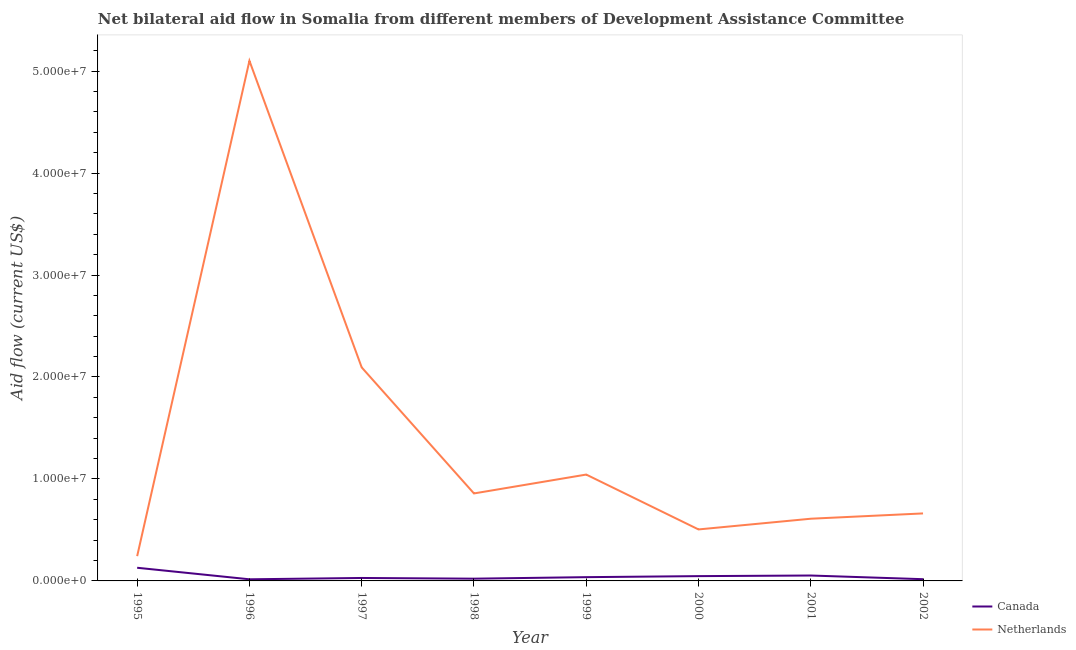What is the amount of aid given by canada in 1995?
Make the answer very short. 1.29e+06. Across all years, what is the maximum amount of aid given by canada?
Provide a short and direct response. 1.29e+06. Across all years, what is the minimum amount of aid given by netherlands?
Offer a very short reply. 2.43e+06. In which year was the amount of aid given by netherlands minimum?
Keep it short and to the point. 1995. What is the total amount of aid given by canada in the graph?
Give a very brief answer. 3.50e+06. What is the difference between the amount of aid given by netherlands in 1998 and that in 1999?
Your answer should be compact. -1.85e+06. What is the difference between the amount of aid given by netherlands in 1997 and the amount of aid given by canada in 1998?
Ensure brevity in your answer.  2.07e+07. What is the average amount of aid given by netherlands per year?
Your response must be concise. 1.39e+07. In the year 2000, what is the difference between the amount of aid given by canada and amount of aid given by netherlands?
Your answer should be compact. -4.58e+06. What is the ratio of the amount of aid given by netherlands in 1999 to that in 2000?
Provide a succinct answer. 2.07. What is the difference between the highest and the second highest amount of aid given by canada?
Offer a terse response. 7.60e+05. What is the difference between the highest and the lowest amount of aid given by netherlands?
Provide a succinct answer. 4.86e+07. In how many years, is the amount of aid given by netherlands greater than the average amount of aid given by netherlands taken over all years?
Offer a terse response. 2. Is the sum of the amount of aid given by netherlands in 2000 and 2002 greater than the maximum amount of aid given by canada across all years?
Your response must be concise. Yes. Is the amount of aid given by netherlands strictly greater than the amount of aid given by canada over the years?
Your answer should be very brief. Yes. Is the amount of aid given by canada strictly less than the amount of aid given by netherlands over the years?
Give a very brief answer. Yes. Does the graph contain any zero values?
Offer a terse response. No. Where does the legend appear in the graph?
Ensure brevity in your answer.  Bottom right. How are the legend labels stacked?
Your answer should be compact. Vertical. What is the title of the graph?
Make the answer very short. Net bilateral aid flow in Somalia from different members of Development Assistance Committee. What is the label or title of the X-axis?
Provide a succinct answer. Year. What is the Aid flow (current US$) of Canada in 1995?
Your response must be concise. 1.29e+06. What is the Aid flow (current US$) of Netherlands in 1995?
Provide a succinct answer. 2.43e+06. What is the Aid flow (current US$) in Canada in 1996?
Give a very brief answer. 1.60e+05. What is the Aid flow (current US$) in Netherlands in 1996?
Your answer should be very brief. 5.10e+07. What is the Aid flow (current US$) of Canada in 1997?
Your response must be concise. 2.90e+05. What is the Aid flow (current US$) of Netherlands in 1997?
Ensure brevity in your answer.  2.09e+07. What is the Aid flow (current US$) of Canada in 1998?
Offer a terse response. 2.20e+05. What is the Aid flow (current US$) in Netherlands in 1998?
Your answer should be very brief. 8.58e+06. What is the Aid flow (current US$) in Canada in 1999?
Keep it short and to the point. 3.70e+05. What is the Aid flow (current US$) in Netherlands in 1999?
Your response must be concise. 1.04e+07. What is the Aid flow (current US$) of Canada in 2000?
Provide a succinct answer. 4.70e+05. What is the Aid flow (current US$) in Netherlands in 2000?
Your answer should be very brief. 5.05e+06. What is the Aid flow (current US$) in Canada in 2001?
Make the answer very short. 5.30e+05. What is the Aid flow (current US$) in Netherlands in 2001?
Your answer should be compact. 6.10e+06. What is the Aid flow (current US$) in Netherlands in 2002?
Give a very brief answer. 6.62e+06. Across all years, what is the maximum Aid flow (current US$) of Canada?
Ensure brevity in your answer.  1.29e+06. Across all years, what is the maximum Aid flow (current US$) of Netherlands?
Offer a terse response. 5.10e+07. Across all years, what is the minimum Aid flow (current US$) in Canada?
Offer a very short reply. 1.60e+05. Across all years, what is the minimum Aid flow (current US$) in Netherlands?
Give a very brief answer. 2.43e+06. What is the total Aid flow (current US$) in Canada in the graph?
Make the answer very short. 3.50e+06. What is the total Aid flow (current US$) of Netherlands in the graph?
Provide a short and direct response. 1.11e+08. What is the difference between the Aid flow (current US$) of Canada in 1995 and that in 1996?
Provide a succinct answer. 1.13e+06. What is the difference between the Aid flow (current US$) in Netherlands in 1995 and that in 1996?
Provide a succinct answer. -4.86e+07. What is the difference between the Aid flow (current US$) in Netherlands in 1995 and that in 1997?
Offer a terse response. -1.85e+07. What is the difference between the Aid flow (current US$) of Canada in 1995 and that in 1998?
Ensure brevity in your answer.  1.07e+06. What is the difference between the Aid flow (current US$) in Netherlands in 1995 and that in 1998?
Make the answer very short. -6.15e+06. What is the difference between the Aid flow (current US$) in Canada in 1995 and that in 1999?
Your answer should be compact. 9.20e+05. What is the difference between the Aid flow (current US$) of Netherlands in 1995 and that in 1999?
Offer a terse response. -8.00e+06. What is the difference between the Aid flow (current US$) in Canada in 1995 and that in 2000?
Provide a succinct answer. 8.20e+05. What is the difference between the Aid flow (current US$) of Netherlands in 1995 and that in 2000?
Offer a very short reply. -2.62e+06. What is the difference between the Aid flow (current US$) in Canada in 1995 and that in 2001?
Your answer should be very brief. 7.60e+05. What is the difference between the Aid flow (current US$) in Netherlands in 1995 and that in 2001?
Ensure brevity in your answer.  -3.67e+06. What is the difference between the Aid flow (current US$) of Canada in 1995 and that in 2002?
Your answer should be very brief. 1.12e+06. What is the difference between the Aid flow (current US$) of Netherlands in 1995 and that in 2002?
Make the answer very short. -4.19e+06. What is the difference between the Aid flow (current US$) in Canada in 1996 and that in 1997?
Your answer should be very brief. -1.30e+05. What is the difference between the Aid flow (current US$) in Netherlands in 1996 and that in 1997?
Your answer should be compact. 3.01e+07. What is the difference between the Aid flow (current US$) in Canada in 1996 and that in 1998?
Make the answer very short. -6.00e+04. What is the difference between the Aid flow (current US$) of Netherlands in 1996 and that in 1998?
Provide a short and direct response. 4.24e+07. What is the difference between the Aid flow (current US$) of Netherlands in 1996 and that in 1999?
Make the answer very short. 4.06e+07. What is the difference between the Aid flow (current US$) in Canada in 1996 and that in 2000?
Keep it short and to the point. -3.10e+05. What is the difference between the Aid flow (current US$) in Netherlands in 1996 and that in 2000?
Provide a short and direct response. 4.60e+07. What is the difference between the Aid flow (current US$) in Canada in 1996 and that in 2001?
Provide a short and direct response. -3.70e+05. What is the difference between the Aid flow (current US$) of Netherlands in 1996 and that in 2001?
Offer a very short reply. 4.49e+07. What is the difference between the Aid flow (current US$) in Canada in 1996 and that in 2002?
Provide a succinct answer. -10000. What is the difference between the Aid flow (current US$) of Netherlands in 1996 and that in 2002?
Your answer should be compact. 4.44e+07. What is the difference between the Aid flow (current US$) of Canada in 1997 and that in 1998?
Keep it short and to the point. 7.00e+04. What is the difference between the Aid flow (current US$) of Netherlands in 1997 and that in 1998?
Offer a very short reply. 1.24e+07. What is the difference between the Aid flow (current US$) of Netherlands in 1997 and that in 1999?
Offer a very short reply. 1.05e+07. What is the difference between the Aid flow (current US$) in Canada in 1997 and that in 2000?
Your answer should be compact. -1.80e+05. What is the difference between the Aid flow (current US$) of Netherlands in 1997 and that in 2000?
Give a very brief answer. 1.59e+07. What is the difference between the Aid flow (current US$) in Canada in 1997 and that in 2001?
Keep it short and to the point. -2.40e+05. What is the difference between the Aid flow (current US$) in Netherlands in 1997 and that in 2001?
Offer a very short reply. 1.48e+07. What is the difference between the Aid flow (current US$) in Netherlands in 1997 and that in 2002?
Your answer should be compact. 1.43e+07. What is the difference between the Aid flow (current US$) of Netherlands in 1998 and that in 1999?
Ensure brevity in your answer.  -1.85e+06. What is the difference between the Aid flow (current US$) in Canada in 1998 and that in 2000?
Offer a terse response. -2.50e+05. What is the difference between the Aid flow (current US$) of Netherlands in 1998 and that in 2000?
Your response must be concise. 3.53e+06. What is the difference between the Aid flow (current US$) in Canada in 1998 and that in 2001?
Keep it short and to the point. -3.10e+05. What is the difference between the Aid flow (current US$) in Netherlands in 1998 and that in 2001?
Your answer should be compact. 2.48e+06. What is the difference between the Aid flow (current US$) in Netherlands in 1998 and that in 2002?
Your answer should be compact. 1.96e+06. What is the difference between the Aid flow (current US$) in Netherlands in 1999 and that in 2000?
Your answer should be very brief. 5.38e+06. What is the difference between the Aid flow (current US$) in Canada in 1999 and that in 2001?
Make the answer very short. -1.60e+05. What is the difference between the Aid flow (current US$) of Netherlands in 1999 and that in 2001?
Provide a succinct answer. 4.33e+06. What is the difference between the Aid flow (current US$) in Canada in 1999 and that in 2002?
Offer a very short reply. 2.00e+05. What is the difference between the Aid flow (current US$) of Netherlands in 1999 and that in 2002?
Provide a short and direct response. 3.81e+06. What is the difference between the Aid flow (current US$) in Canada in 2000 and that in 2001?
Ensure brevity in your answer.  -6.00e+04. What is the difference between the Aid flow (current US$) of Netherlands in 2000 and that in 2001?
Make the answer very short. -1.05e+06. What is the difference between the Aid flow (current US$) in Netherlands in 2000 and that in 2002?
Keep it short and to the point. -1.57e+06. What is the difference between the Aid flow (current US$) in Netherlands in 2001 and that in 2002?
Provide a succinct answer. -5.20e+05. What is the difference between the Aid flow (current US$) in Canada in 1995 and the Aid flow (current US$) in Netherlands in 1996?
Keep it short and to the point. -4.97e+07. What is the difference between the Aid flow (current US$) of Canada in 1995 and the Aid flow (current US$) of Netherlands in 1997?
Offer a very short reply. -1.96e+07. What is the difference between the Aid flow (current US$) in Canada in 1995 and the Aid flow (current US$) in Netherlands in 1998?
Offer a terse response. -7.29e+06. What is the difference between the Aid flow (current US$) in Canada in 1995 and the Aid flow (current US$) in Netherlands in 1999?
Make the answer very short. -9.14e+06. What is the difference between the Aid flow (current US$) of Canada in 1995 and the Aid flow (current US$) of Netherlands in 2000?
Ensure brevity in your answer.  -3.76e+06. What is the difference between the Aid flow (current US$) of Canada in 1995 and the Aid flow (current US$) of Netherlands in 2001?
Make the answer very short. -4.81e+06. What is the difference between the Aid flow (current US$) of Canada in 1995 and the Aid flow (current US$) of Netherlands in 2002?
Offer a very short reply. -5.33e+06. What is the difference between the Aid flow (current US$) of Canada in 1996 and the Aid flow (current US$) of Netherlands in 1997?
Provide a short and direct response. -2.08e+07. What is the difference between the Aid flow (current US$) of Canada in 1996 and the Aid flow (current US$) of Netherlands in 1998?
Provide a short and direct response. -8.42e+06. What is the difference between the Aid flow (current US$) of Canada in 1996 and the Aid flow (current US$) of Netherlands in 1999?
Offer a very short reply. -1.03e+07. What is the difference between the Aid flow (current US$) in Canada in 1996 and the Aid flow (current US$) in Netherlands in 2000?
Keep it short and to the point. -4.89e+06. What is the difference between the Aid flow (current US$) of Canada in 1996 and the Aid flow (current US$) of Netherlands in 2001?
Make the answer very short. -5.94e+06. What is the difference between the Aid flow (current US$) of Canada in 1996 and the Aid flow (current US$) of Netherlands in 2002?
Offer a very short reply. -6.46e+06. What is the difference between the Aid flow (current US$) of Canada in 1997 and the Aid flow (current US$) of Netherlands in 1998?
Offer a terse response. -8.29e+06. What is the difference between the Aid flow (current US$) in Canada in 1997 and the Aid flow (current US$) in Netherlands in 1999?
Your answer should be very brief. -1.01e+07. What is the difference between the Aid flow (current US$) in Canada in 1997 and the Aid flow (current US$) in Netherlands in 2000?
Give a very brief answer. -4.76e+06. What is the difference between the Aid flow (current US$) of Canada in 1997 and the Aid flow (current US$) of Netherlands in 2001?
Keep it short and to the point. -5.81e+06. What is the difference between the Aid flow (current US$) of Canada in 1997 and the Aid flow (current US$) of Netherlands in 2002?
Provide a short and direct response. -6.33e+06. What is the difference between the Aid flow (current US$) of Canada in 1998 and the Aid flow (current US$) of Netherlands in 1999?
Your response must be concise. -1.02e+07. What is the difference between the Aid flow (current US$) of Canada in 1998 and the Aid flow (current US$) of Netherlands in 2000?
Provide a succinct answer. -4.83e+06. What is the difference between the Aid flow (current US$) in Canada in 1998 and the Aid flow (current US$) in Netherlands in 2001?
Provide a succinct answer. -5.88e+06. What is the difference between the Aid flow (current US$) of Canada in 1998 and the Aid flow (current US$) of Netherlands in 2002?
Your response must be concise. -6.40e+06. What is the difference between the Aid flow (current US$) in Canada in 1999 and the Aid flow (current US$) in Netherlands in 2000?
Keep it short and to the point. -4.68e+06. What is the difference between the Aid flow (current US$) in Canada in 1999 and the Aid flow (current US$) in Netherlands in 2001?
Offer a terse response. -5.73e+06. What is the difference between the Aid flow (current US$) in Canada in 1999 and the Aid flow (current US$) in Netherlands in 2002?
Give a very brief answer. -6.25e+06. What is the difference between the Aid flow (current US$) of Canada in 2000 and the Aid flow (current US$) of Netherlands in 2001?
Your response must be concise. -5.63e+06. What is the difference between the Aid flow (current US$) of Canada in 2000 and the Aid flow (current US$) of Netherlands in 2002?
Your answer should be very brief. -6.15e+06. What is the difference between the Aid flow (current US$) of Canada in 2001 and the Aid flow (current US$) of Netherlands in 2002?
Provide a succinct answer. -6.09e+06. What is the average Aid flow (current US$) in Canada per year?
Ensure brevity in your answer.  4.38e+05. What is the average Aid flow (current US$) of Netherlands per year?
Ensure brevity in your answer.  1.39e+07. In the year 1995, what is the difference between the Aid flow (current US$) of Canada and Aid flow (current US$) of Netherlands?
Your answer should be very brief. -1.14e+06. In the year 1996, what is the difference between the Aid flow (current US$) of Canada and Aid flow (current US$) of Netherlands?
Provide a short and direct response. -5.08e+07. In the year 1997, what is the difference between the Aid flow (current US$) of Canada and Aid flow (current US$) of Netherlands?
Offer a very short reply. -2.06e+07. In the year 1998, what is the difference between the Aid flow (current US$) in Canada and Aid flow (current US$) in Netherlands?
Your answer should be very brief. -8.36e+06. In the year 1999, what is the difference between the Aid flow (current US$) of Canada and Aid flow (current US$) of Netherlands?
Ensure brevity in your answer.  -1.01e+07. In the year 2000, what is the difference between the Aid flow (current US$) in Canada and Aid flow (current US$) in Netherlands?
Offer a terse response. -4.58e+06. In the year 2001, what is the difference between the Aid flow (current US$) in Canada and Aid flow (current US$) in Netherlands?
Offer a very short reply. -5.57e+06. In the year 2002, what is the difference between the Aid flow (current US$) of Canada and Aid flow (current US$) of Netherlands?
Provide a succinct answer. -6.45e+06. What is the ratio of the Aid flow (current US$) of Canada in 1995 to that in 1996?
Keep it short and to the point. 8.06. What is the ratio of the Aid flow (current US$) of Netherlands in 1995 to that in 1996?
Your answer should be very brief. 0.05. What is the ratio of the Aid flow (current US$) of Canada in 1995 to that in 1997?
Your answer should be compact. 4.45. What is the ratio of the Aid flow (current US$) of Netherlands in 1995 to that in 1997?
Provide a short and direct response. 0.12. What is the ratio of the Aid flow (current US$) in Canada in 1995 to that in 1998?
Provide a succinct answer. 5.86. What is the ratio of the Aid flow (current US$) in Netherlands in 1995 to that in 1998?
Ensure brevity in your answer.  0.28. What is the ratio of the Aid flow (current US$) of Canada in 1995 to that in 1999?
Give a very brief answer. 3.49. What is the ratio of the Aid flow (current US$) in Netherlands in 1995 to that in 1999?
Ensure brevity in your answer.  0.23. What is the ratio of the Aid flow (current US$) in Canada in 1995 to that in 2000?
Offer a very short reply. 2.74. What is the ratio of the Aid flow (current US$) of Netherlands in 1995 to that in 2000?
Provide a short and direct response. 0.48. What is the ratio of the Aid flow (current US$) in Canada in 1995 to that in 2001?
Make the answer very short. 2.43. What is the ratio of the Aid flow (current US$) of Netherlands in 1995 to that in 2001?
Your response must be concise. 0.4. What is the ratio of the Aid flow (current US$) in Canada in 1995 to that in 2002?
Your answer should be very brief. 7.59. What is the ratio of the Aid flow (current US$) of Netherlands in 1995 to that in 2002?
Offer a very short reply. 0.37. What is the ratio of the Aid flow (current US$) of Canada in 1996 to that in 1997?
Provide a succinct answer. 0.55. What is the ratio of the Aid flow (current US$) of Netherlands in 1996 to that in 1997?
Your response must be concise. 2.44. What is the ratio of the Aid flow (current US$) of Canada in 1996 to that in 1998?
Keep it short and to the point. 0.73. What is the ratio of the Aid flow (current US$) in Netherlands in 1996 to that in 1998?
Your response must be concise. 5.95. What is the ratio of the Aid flow (current US$) in Canada in 1996 to that in 1999?
Provide a short and direct response. 0.43. What is the ratio of the Aid flow (current US$) of Netherlands in 1996 to that in 1999?
Your answer should be very brief. 4.89. What is the ratio of the Aid flow (current US$) in Canada in 1996 to that in 2000?
Provide a short and direct response. 0.34. What is the ratio of the Aid flow (current US$) in Netherlands in 1996 to that in 2000?
Ensure brevity in your answer.  10.1. What is the ratio of the Aid flow (current US$) of Canada in 1996 to that in 2001?
Offer a very short reply. 0.3. What is the ratio of the Aid flow (current US$) of Netherlands in 1996 to that in 2001?
Give a very brief answer. 8.36. What is the ratio of the Aid flow (current US$) in Canada in 1996 to that in 2002?
Make the answer very short. 0.94. What is the ratio of the Aid flow (current US$) in Netherlands in 1996 to that in 2002?
Offer a terse response. 7.71. What is the ratio of the Aid flow (current US$) in Canada in 1997 to that in 1998?
Provide a succinct answer. 1.32. What is the ratio of the Aid flow (current US$) in Netherlands in 1997 to that in 1998?
Provide a succinct answer. 2.44. What is the ratio of the Aid flow (current US$) of Canada in 1997 to that in 1999?
Ensure brevity in your answer.  0.78. What is the ratio of the Aid flow (current US$) of Netherlands in 1997 to that in 1999?
Give a very brief answer. 2.01. What is the ratio of the Aid flow (current US$) in Canada in 1997 to that in 2000?
Give a very brief answer. 0.62. What is the ratio of the Aid flow (current US$) in Netherlands in 1997 to that in 2000?
Provide a short and direct response. 4.15. What is the ratio of the Aid flow (current US$) of Canada in 1997 to that in 2001?
Ensure brevity in your answer.  0.55. What is the ratio of the Aid flow (current US$) of Netherlands in 1997 to that in 2001?
Give a very brief answer. 3.43. What is the ratio of the Aid flow (current US$) of Canada in 1997 to that in 2002?
Ensure brevity in your answer.  1.71. What is the ratio of the Aid flow (current US$) of Netherlands in 1997 to that in 2002?
Offer a very short reply. 3.16. What is the ratio of the Aid flow (current US$) in Canada in 1998 to that in 1999?
Give a very brief answer. 0.59. What is the ratio of the Aid flow (current US$) in Netherlands in 1998 to that in 1999?
Your answer should be very brief. 0.82. What is the ratio of the Aid flow (current US$) in Canada in 1998 to that in 2000?
Your response must be concise. 0.47. What is the ratio of the Aid flow (current US$) in Netherlands in 1998 to that in 2000?
Your response must be concise. 1.7. What is the ratio of the Aid flow (current US$) in Canada in 1998 to that in 2001?
Your answer should be very brief. 0.42. What is the ratio of the Aid flow (current US$) of Netherlands in 1998 to that in 2001?
Provide a succinct answer. 1.41. What is the ratio of the Aid flow (current US$) of Canada in 1998 to that in 2002?
Your answer should be compact. 1.29. What is the ratio of the Aid flow (current US$) of Netherlands in 1998 to that in 2002?
Make the answer very short. 1.3. What is the ratio of the Aid flow (current US$) of Canada in 1999 to that in 2000?
Your answer should be compact. 0.79. What is the ratio of the Aid flow (current US$) of Netherlands in 1999 to that in 2000?
Give a very brief answer. 2.07. What is the ratio of the Aid flow (current US$) in Canada in 1999 to that in 2001?
Your answer should be compact. 0.7. What is the ratio of the Aid flow (current US$) in Netherlands in 1999 to that in 2001?
Make the answer very short. 1.71. What is the ratio of the Aid flow (current US$) of Canada in 1999 to that in 2002?
Make the answer very short. 2.18. What is the ratio of the Aid flow (current US$) of Netherlands in 1999 to that in 2002?
Ensure brevity in your answer.  1.58. What is the ratio of the Aid flow (current US$) of Canada in 2000 to that in 2001?
Your answer should be very brief. 0.89. What is the ratio of the Aid flow (current US$) in Netherlands in 2000 to that in 2001?
Offer a very short reply. 0.83. What is the ratio of the Aid flow (current US$) of Canada in 2000 to that in 2002?
Ensure brevity in your answer.  2.76. What is the ratio of the Aid flow (current US$) in Netherlands in 2000 to that in 2002?
Your answer should be very brief. 0.76. What is the ratio of the Aid flow (current US$) of Canada in 2001 to that in 2002?
Provide a succinct answer. 3.12. What is the ratio of the Aid flow (current US$) in Netherlands in 2001 to that in 2002?
Your answer should be very brief. 0.92. What is the difference between the highest and the second highest Aid flow (current US$) of Canada?
Keep it short and to the point. 7.60e+05. What is the difference between the highest and the second highest Aid flow (current US$) of Netherlands?
Provide a short and direct response. 3.01e+07. What is the difference between the highest and the lowest Aid flow (current US$) of Canada?
Offer a terse response. 1.13e+06. What is the difference between the highest and the lowest Aid flow (current US$) of Netherlands?
Give a very brief answer. 4.86e+07. 